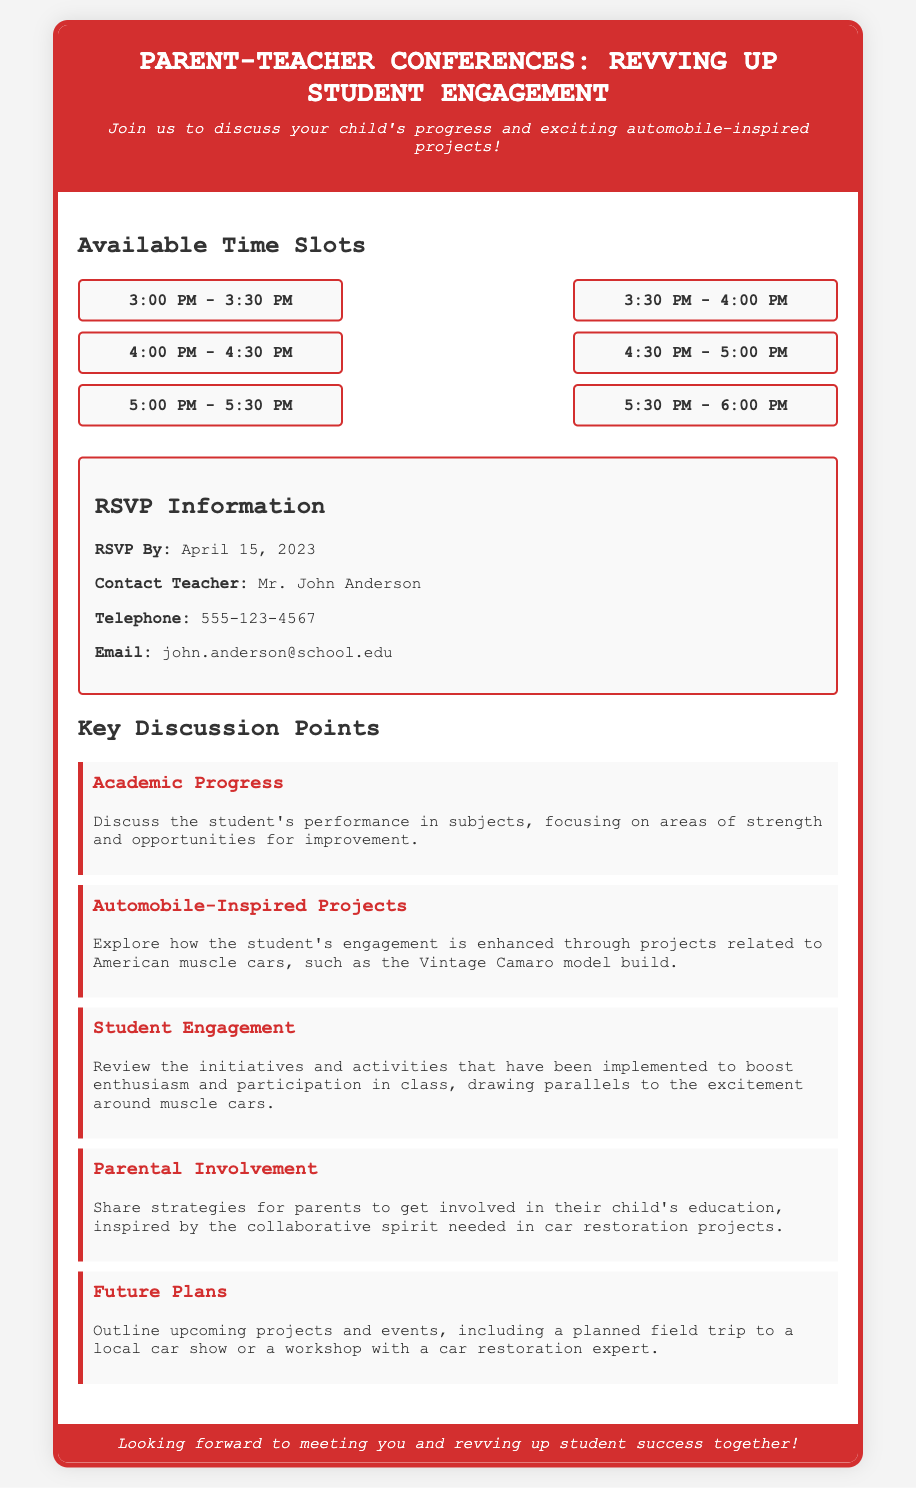What is the RSVP deadline? The RSVP deadline is specified in the document as "April 15, 2023."
Answer: April 15, 2023 Who is the contact teacher? The document states that the contact teacher is "Mr. John Anderson."
Answer: Mr. John Anderson What time slot is available at 4:00 PM? The document lists "4:00 PM - 4:30 PM" as one of the available time slots.
Answer: 4:00 PM - 4:30 PM What is one of the key discussion points regarding student projects? The document mentions discussing "Automobile-Inspired Projects" as a key discussion point.
Answer: Automobile-Inspired Projects How many available time slots are there? The document provides six distinct time slots for the conferences.
Answer: Six 